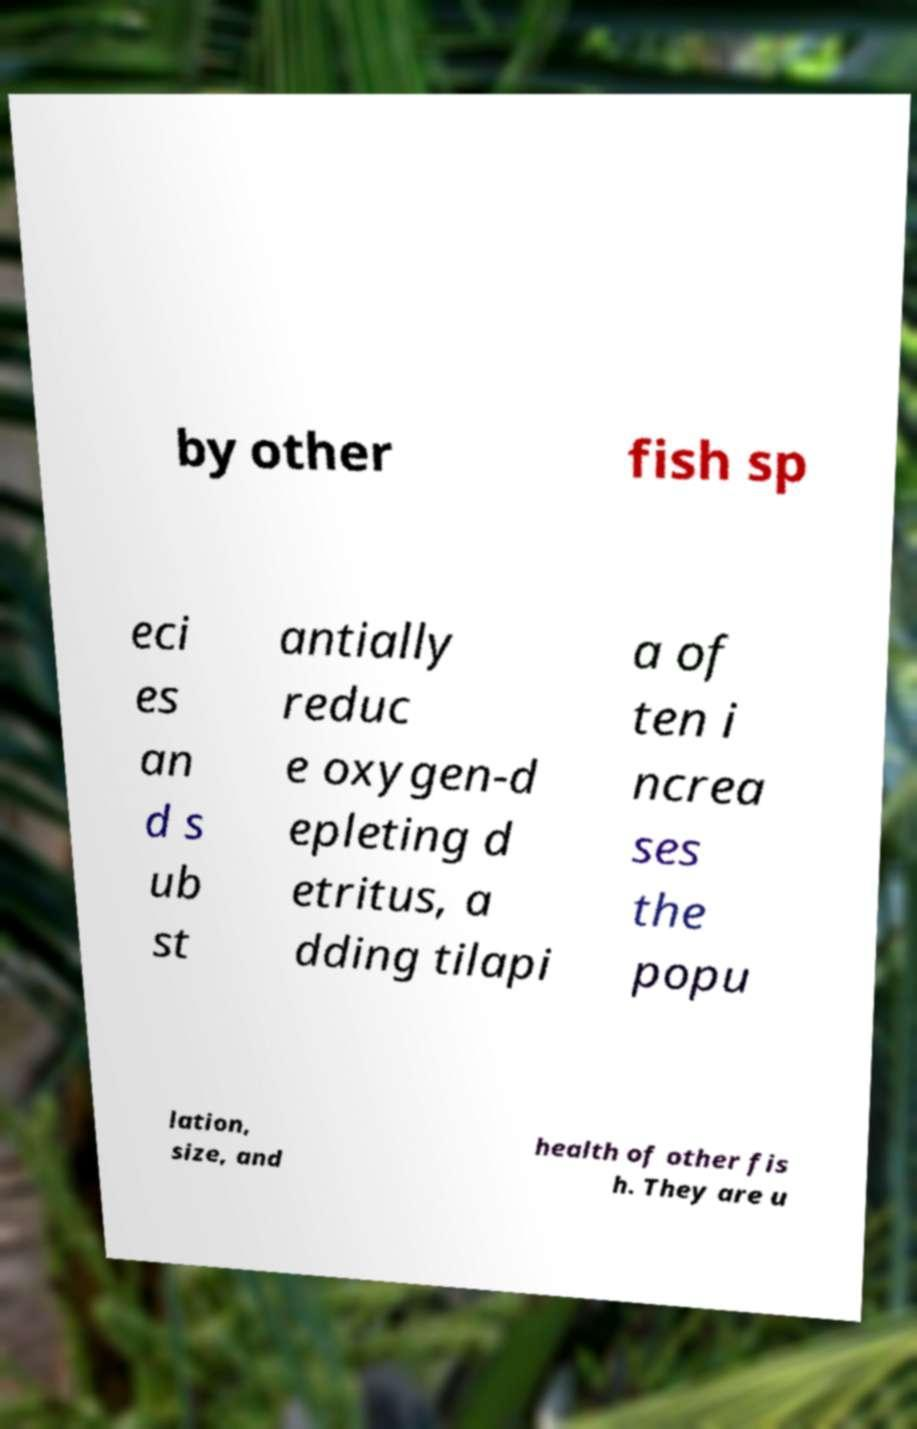What messages or text are displayed in this image? I need them in a readable, typed format. by other fish sp eci es an d s ub st antially reduc e oxygen-d epleting d etritus, a dding tilapi a of ten i ncrea ses the popu lation, size, and health of other fis h. They are u 